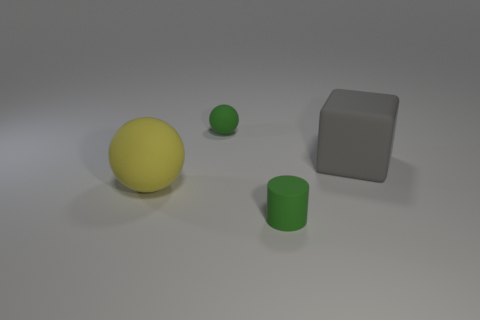Add 1 green rubber balls. How many objects exist? 5 Subtract all cylinders. How many objects are left? 3 Add 2 blocks. How many blocks are left? 3 Add 1 yellow shiny cubes. How many yellow shiny cubes exist? 1 Subtract 0 blue balls. How many objects are left? 4 Subtract all big yellow rubber cylinders. Subtract all small cylinders. How many objects are left? 3 